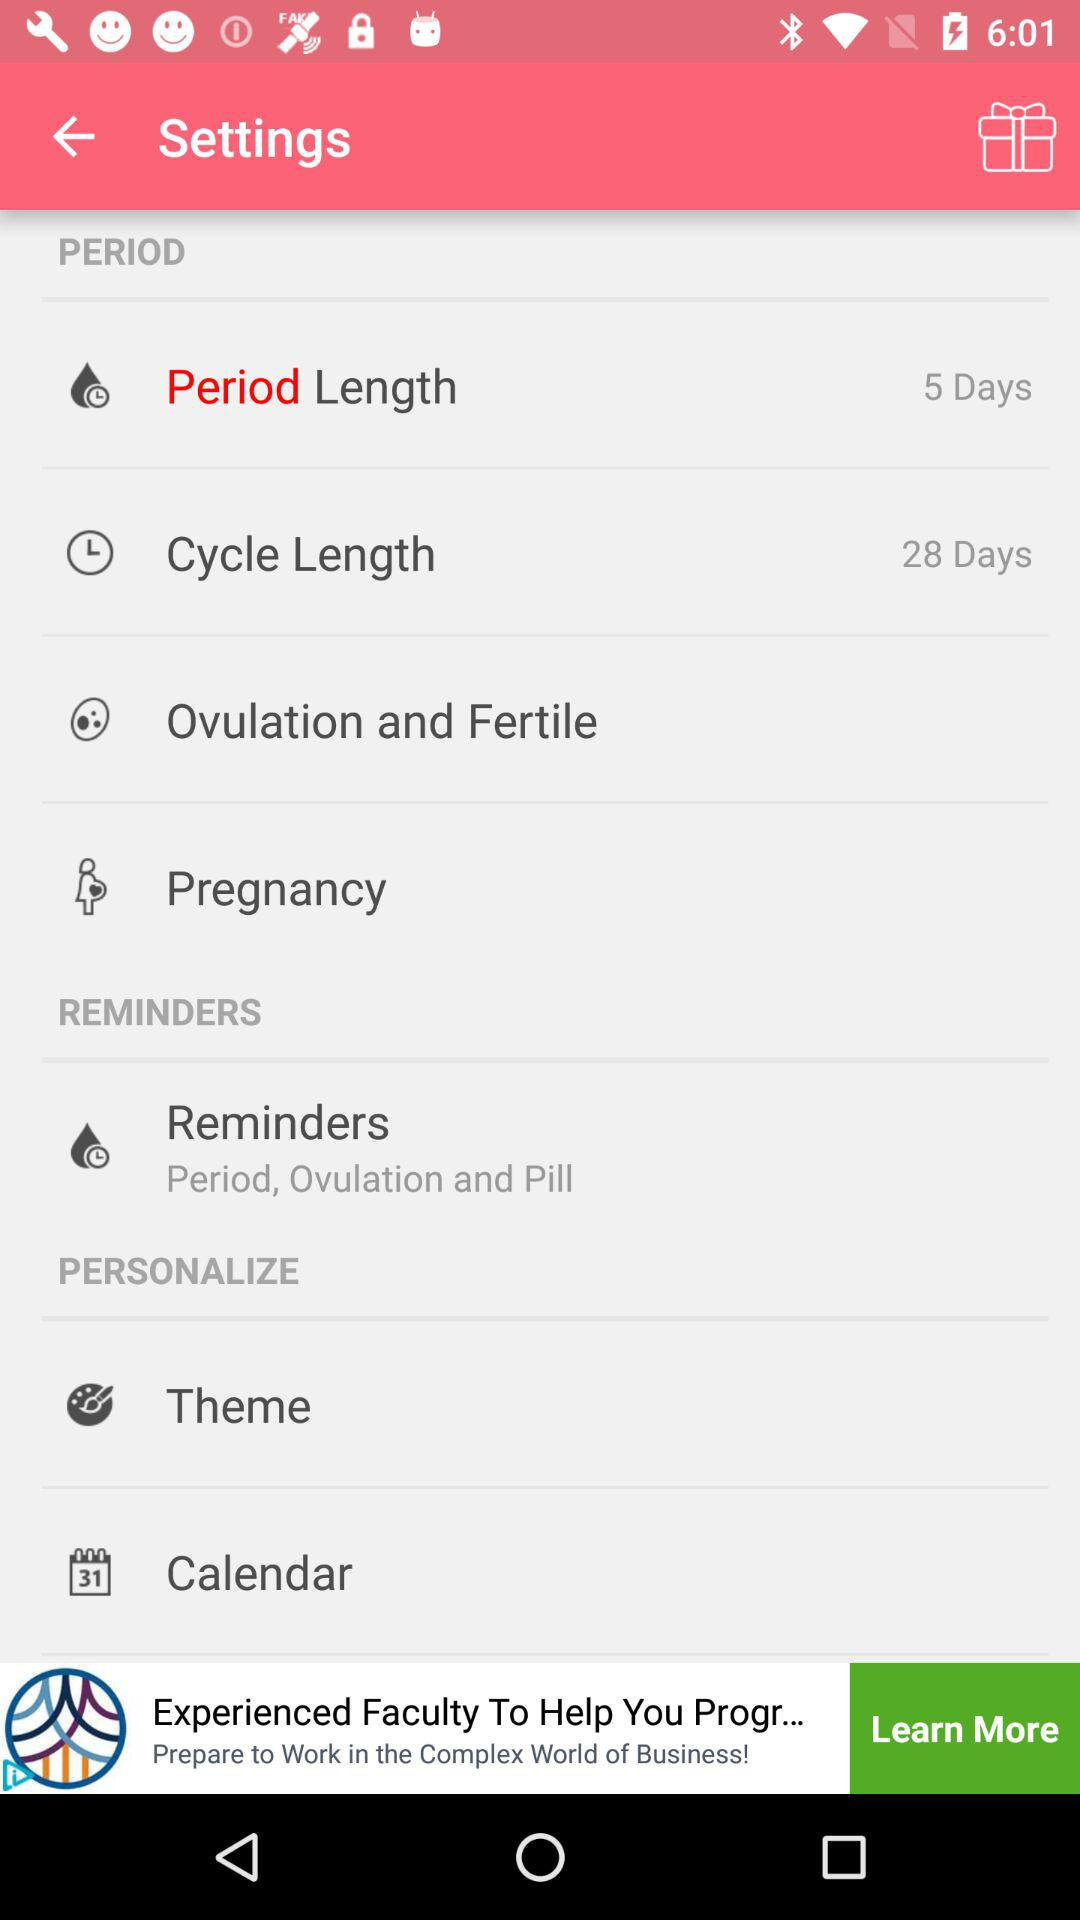What are the reminders about? The reminders about "Period, Ovulation and Pill". 